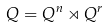Convert formula to latex. <formula><loc_0><loc_0><loc_500><loc_500>Q = Q ^ { n } \rtimes Q ^ { r }</formula> 